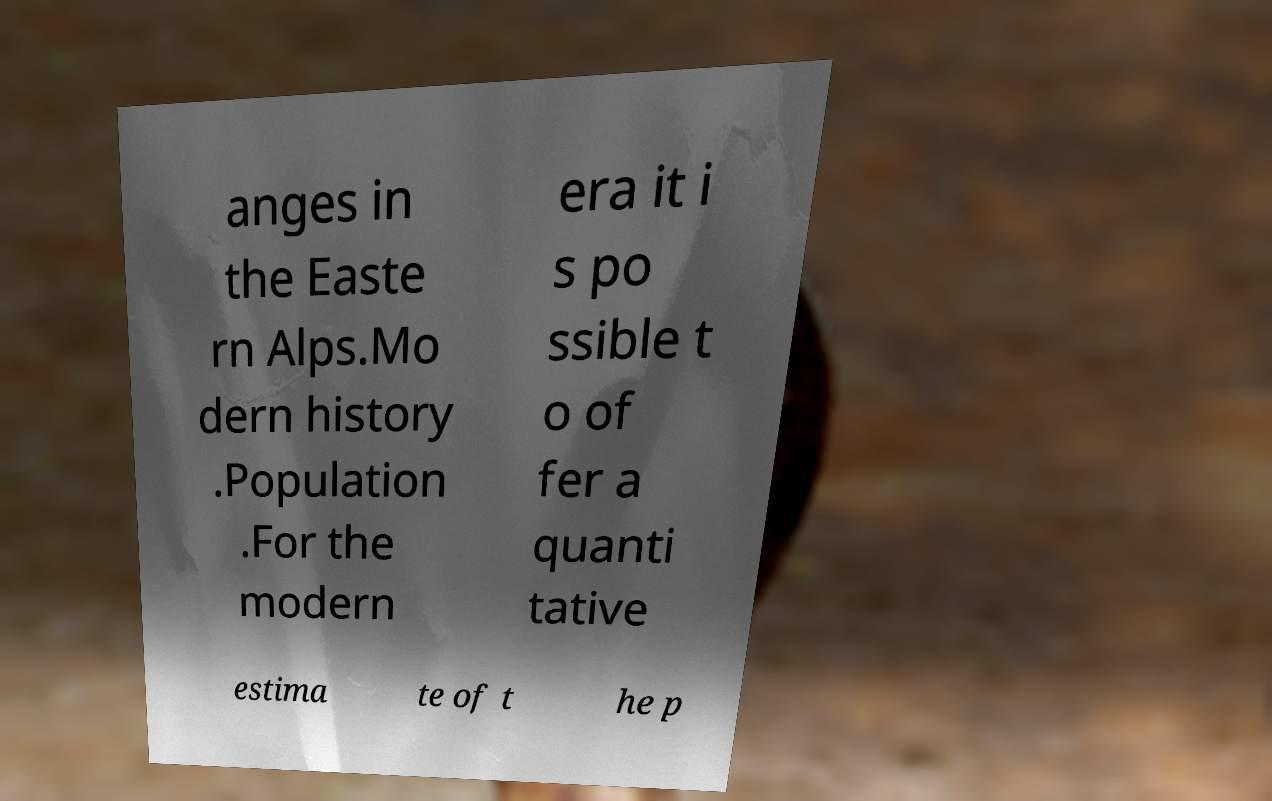There's text embedded in this image that I need extracted. Can you transcribe it verbatim? anges in the Easte rn Alps.Mo dern history .Population .For the modern era it i s po ssible t o of fer a quanti tative estima te of t he p 